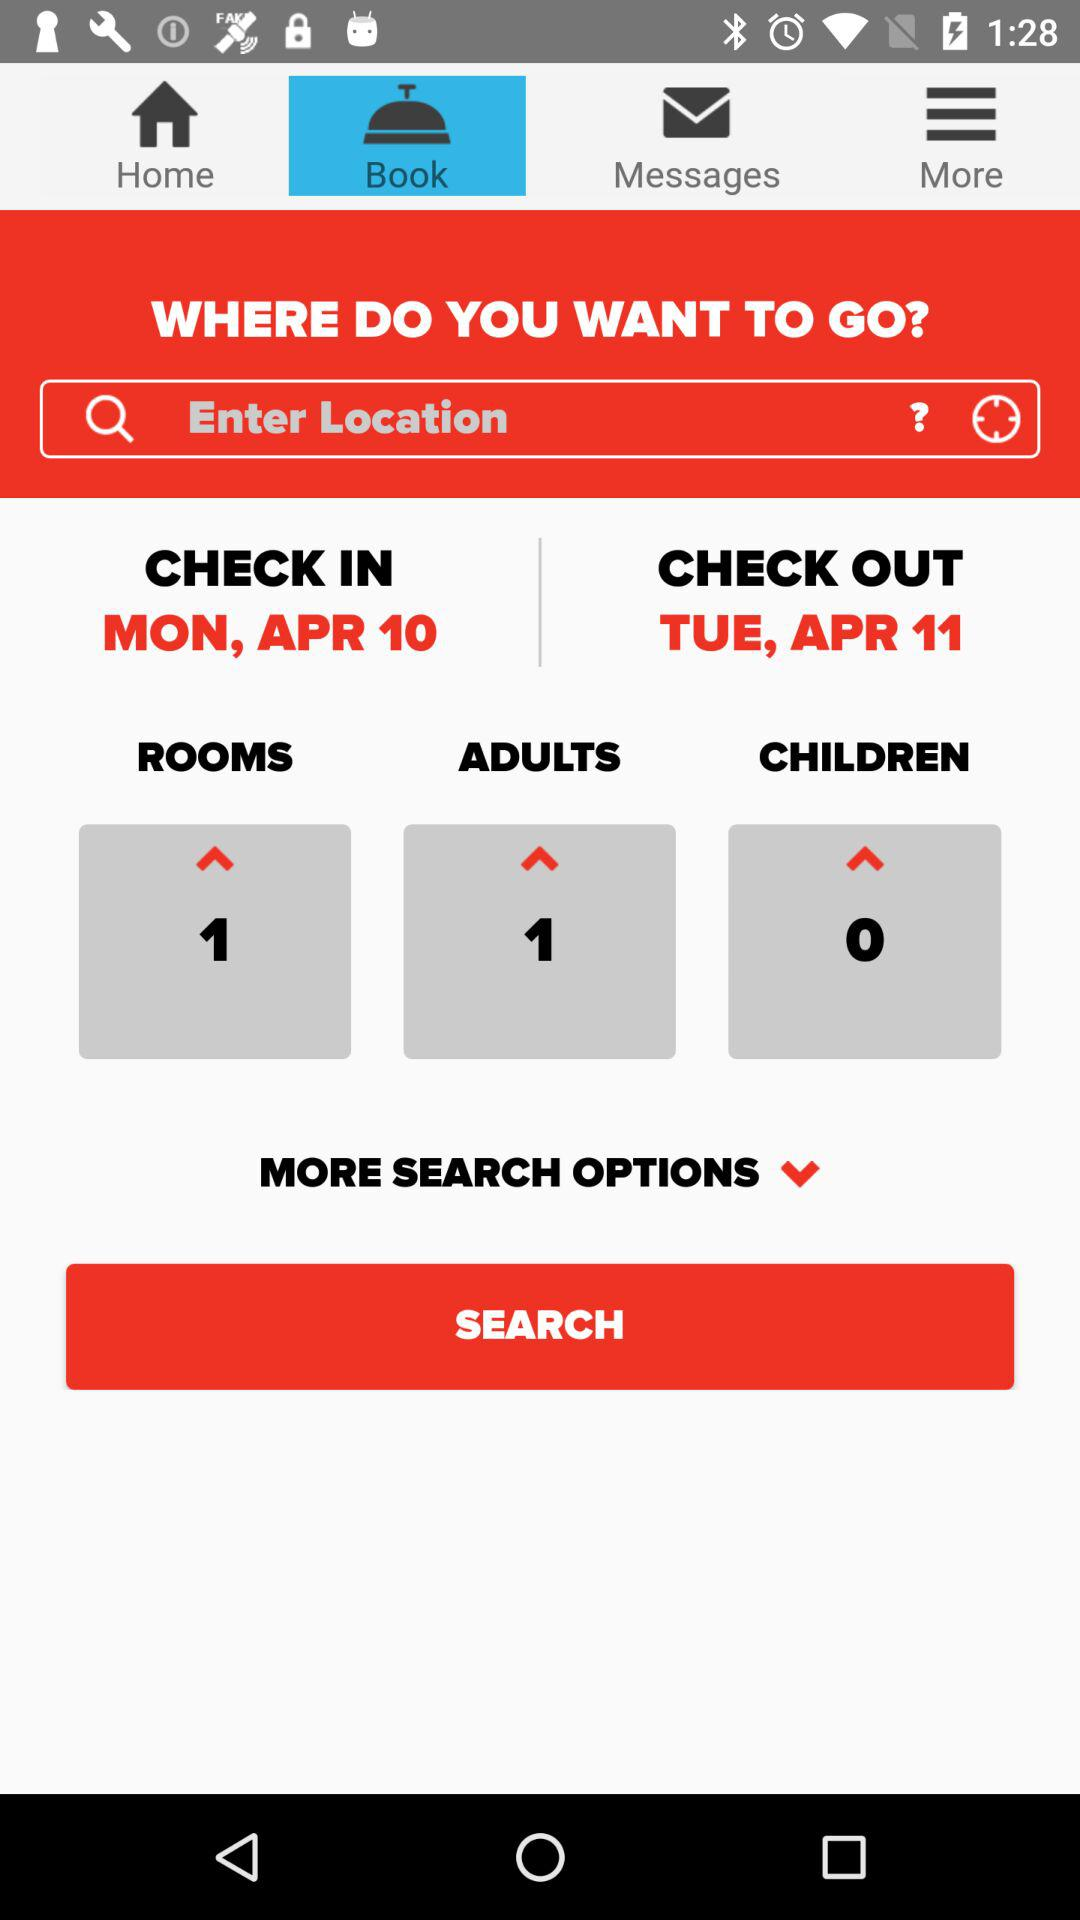How many more rooms are available than children?
Answer the question using a single word or phrase. 1 